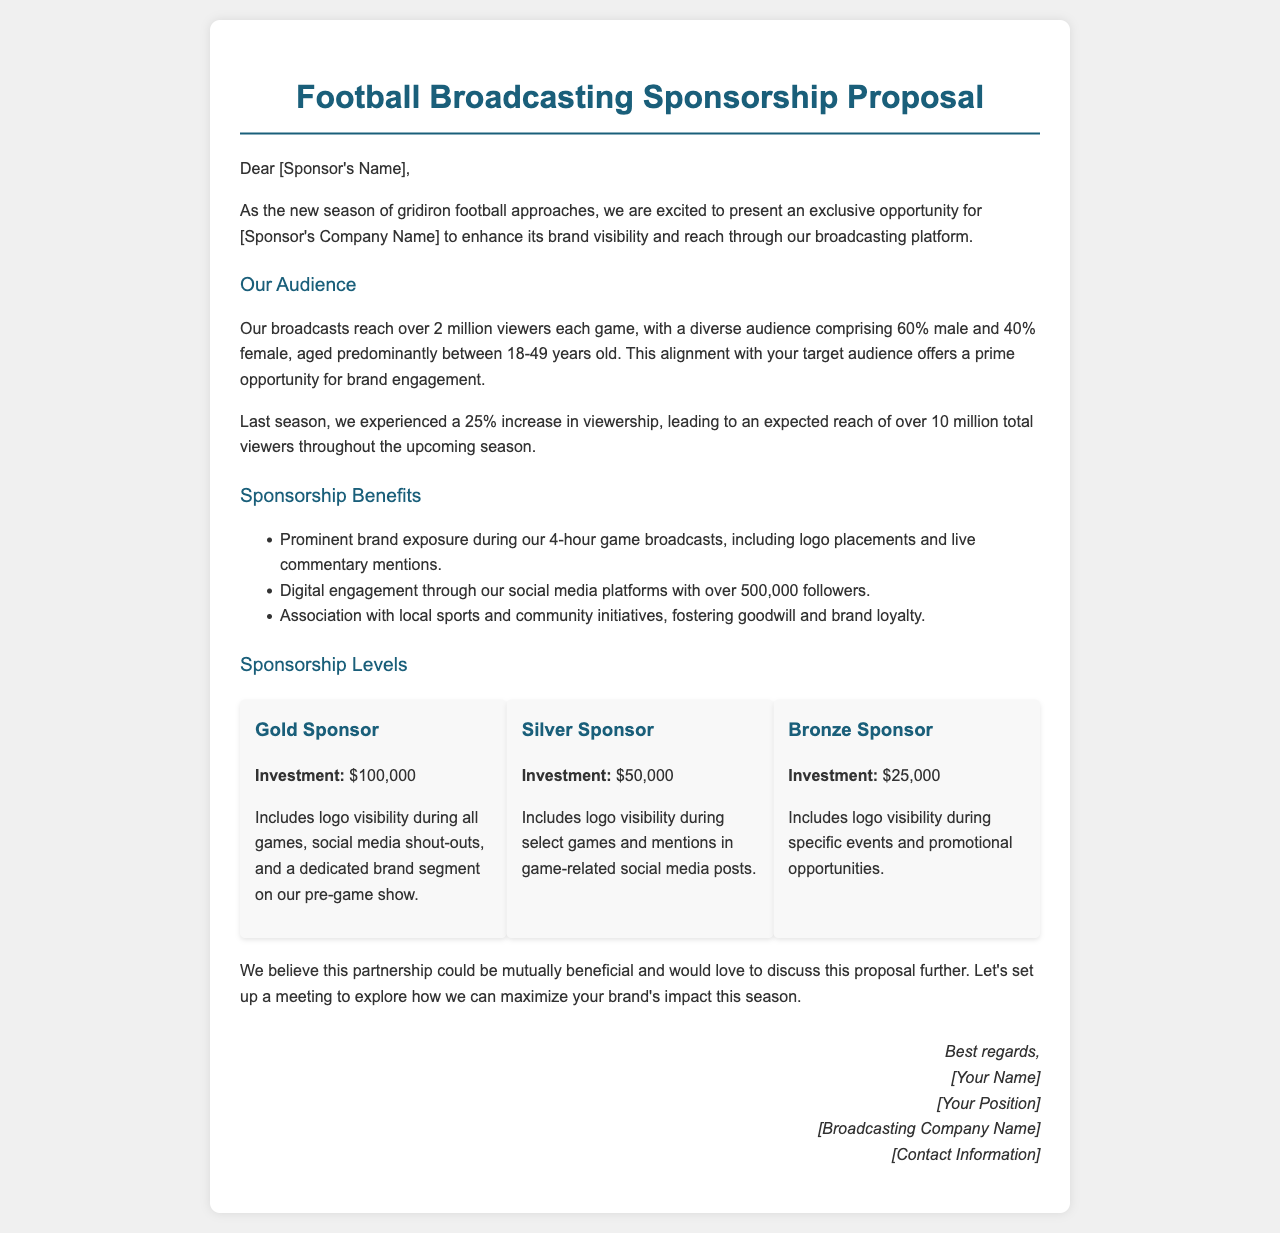What is the title of the document? The title of the document is provided in the header, which states "Football Broadcasting Sponsorship Proposal."
Answer: Football Broadcasting Sponsorship Proposal What is the investment for a Gold Sponsor? The investment amount for a Gold Sponsor is detailed in the section regarding sponsorship levels.
Answer: $100,000 How many viewers does the broadcast reach each game? The document states the reach of the broadcasts per game, which is mentioned in the audience section.
Answer: Over 2 million What percentage of the audience is male? The document indicates the demographic breakdown of the audience, specifying the percentage of males.
Answer: 60% What is one of the benefits listed for sponsors? The document outlines several benefits for sponsors, one of which can be found in the sponsorship benefits section.
Answer: Prominent brand exposure during broadcasts What type of exposure is included for Bronze Sponsors? The document specifies what is included for sponsors at the Bronze level in terms of exposure.
Answer: Logo visibility during specific events What is the total expected reach of viewers throughout the season? The expected viewership for the entire upcoming season is noted in the audience section of the document.
Answer: Over 10 million What is the purpose of the document? The document aims to present a business opportunity for potential sponsors in sports broadcasting.
Answer: Sponsorship proposal What is included in the Silver Sponsor level? The levels of sponsorship detail what is provided at the Silver level in the sponsorship section.
Answer: Logo visibility during select games 